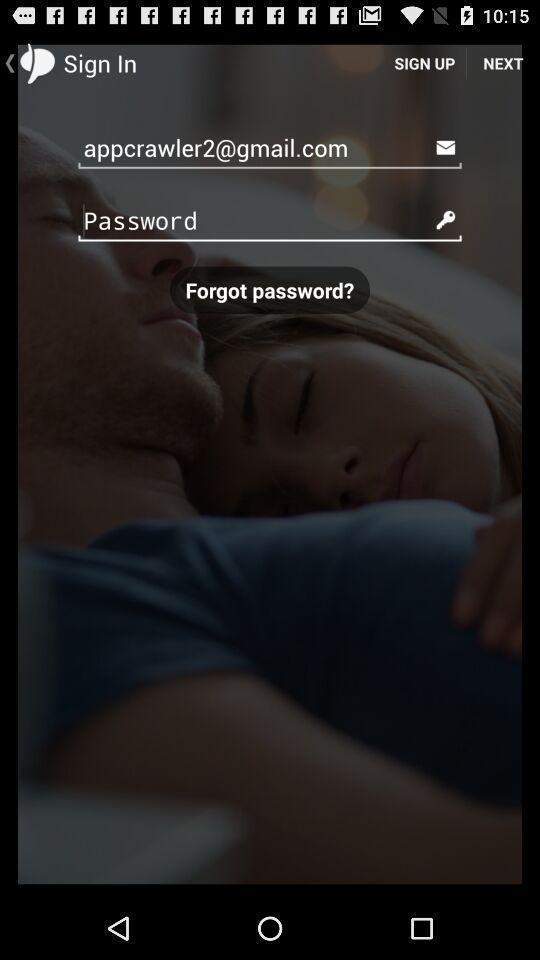Give me a narrative description of this picture. Sign in page of the app. 